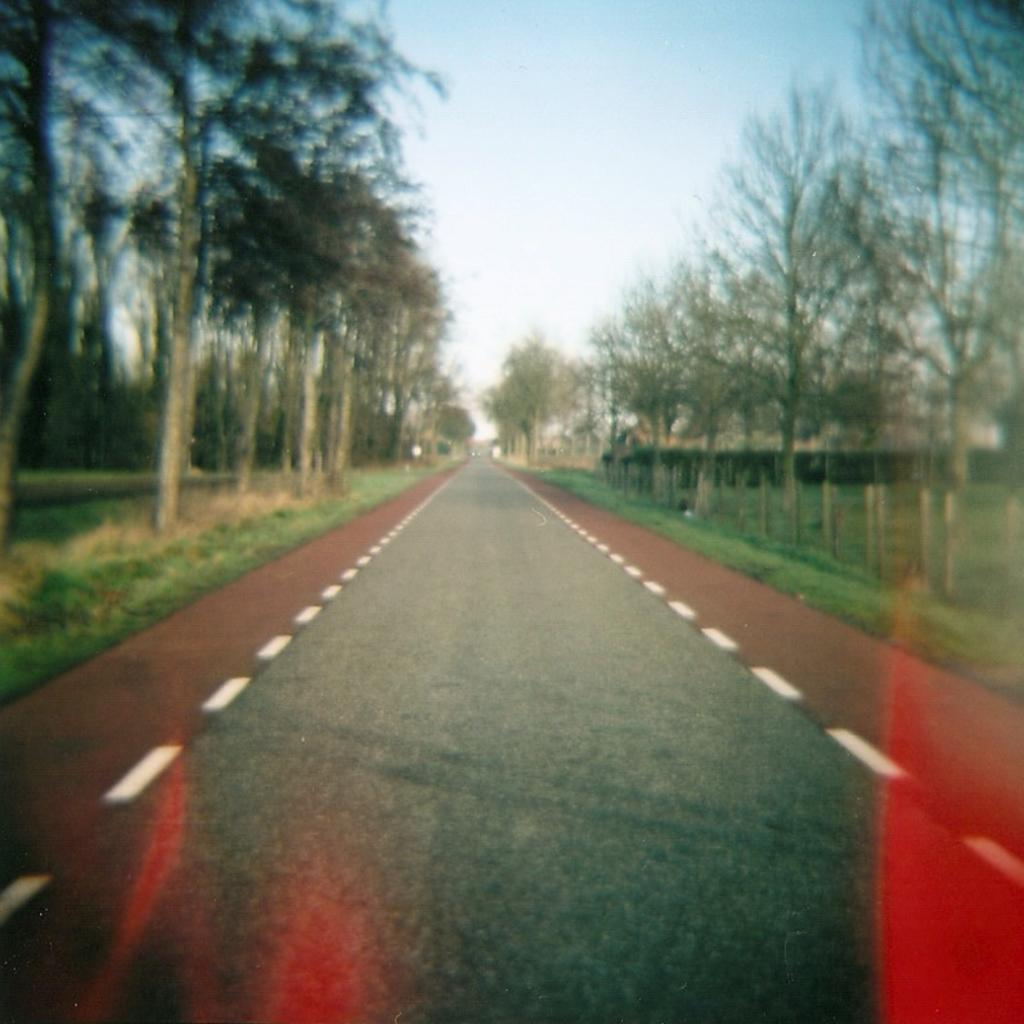What is the main feature of the image? There is a road in the image. How is the road positioned in relation to other elements? The road is situated between trees. What can be seen at the top of the image? The sky is visible at the top of the image. What type of bells can be heard ringing in the image? There are no bells present in the image, and therefore no sound can be heard. 